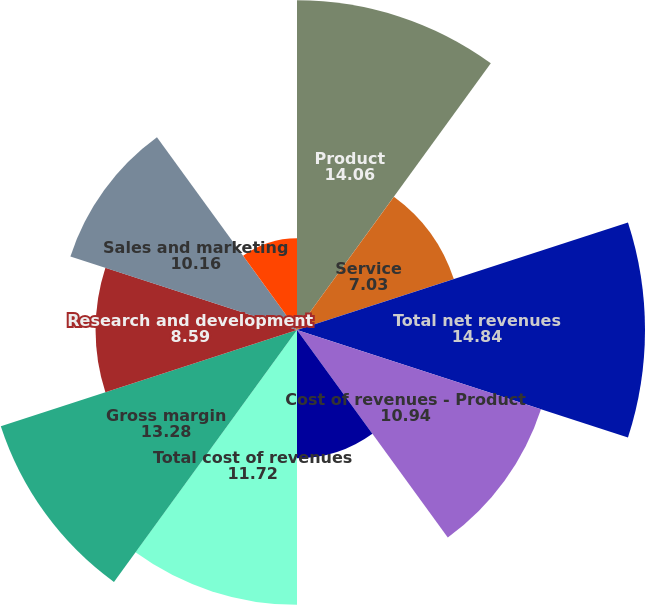Convert chart to OTSL. <chart><loc_0><loc_0><loc_500><loc_500><pie_chart><fcel>Product<fcel>Service<fcel>Total net revenues<fcel>Cost of revenues - Product<fcel>Cost of revenues - Service<fcel>Total cost of revenues<fcel>Gross margin<fcel>Research and development<fcel>Sales and marketing<fcel>General and administrative<nl><fcel>14.06%<fcel>7.03%<fcel>14.84%<fcel>10.94%<fcel>5.47%<fcel>11.72%<fcel>13.28%<fcel>8.59%<fcel>10.16%<fcel>3.91%<nl></chart> 